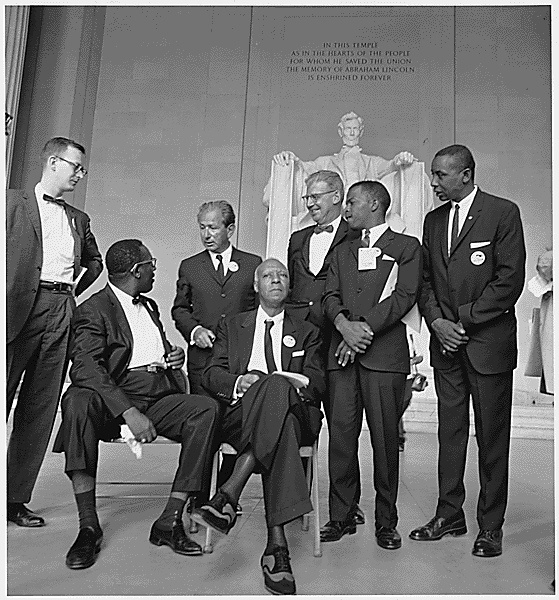Describe the objects in this image and their specific colors. I can see people in white, black, and gray tones, people in white, black, gray, and darkgray tones, people in white, black, gray, lightgray, and darkgray tones, people in white, black, and gray tones, and people in white, black, gray, lightgray, and darkgray tones in this image. 